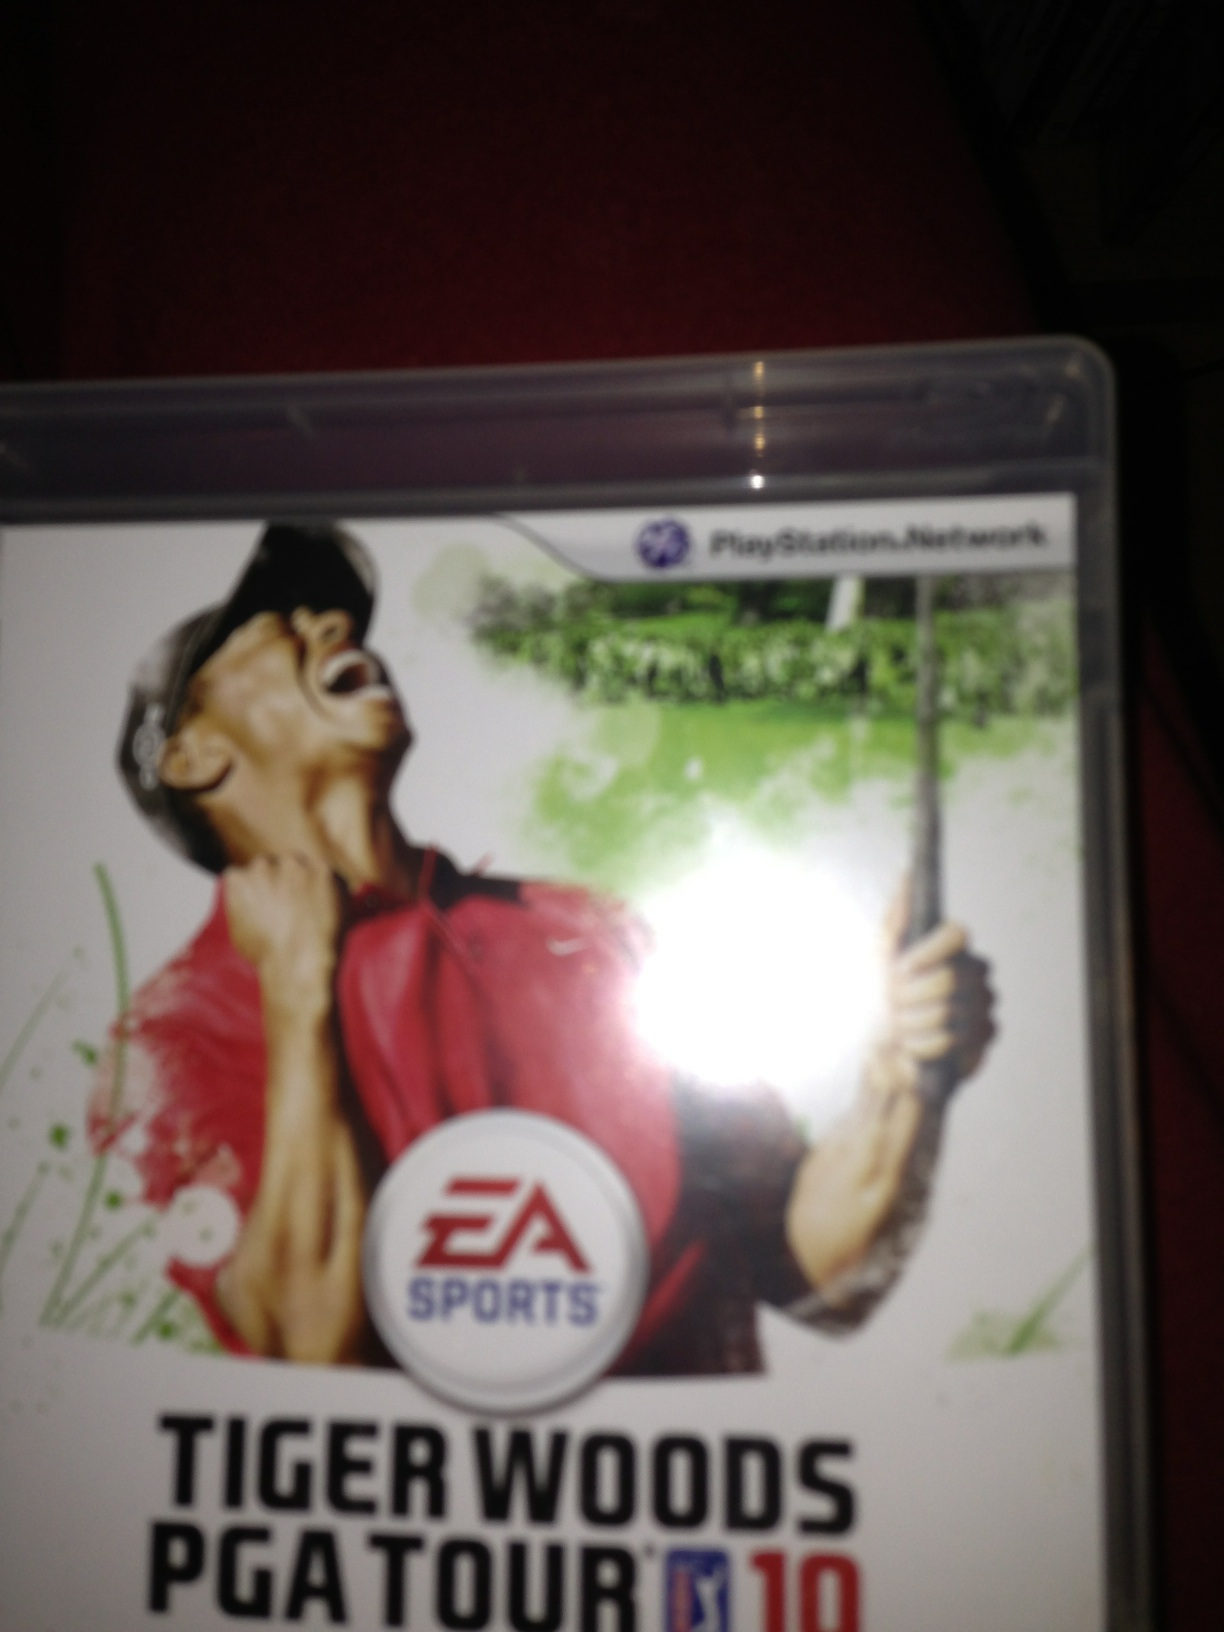What video game is this? The video game shown in the image is 'Tiger Woods PGA Tour 10,' a golf video game part of the popular series developed by EA Sports. The game, available on multiple platforms including PlayStation, features realistic golfing experiences and a variety of courses to play on. 